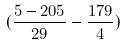<formula> <loc_0><loc_0><loc_500><loc_500>( \frac { 5 - 2 0 5 } { 2 9 } - \frac { 1 7 9 } { 4 } )</formula> 